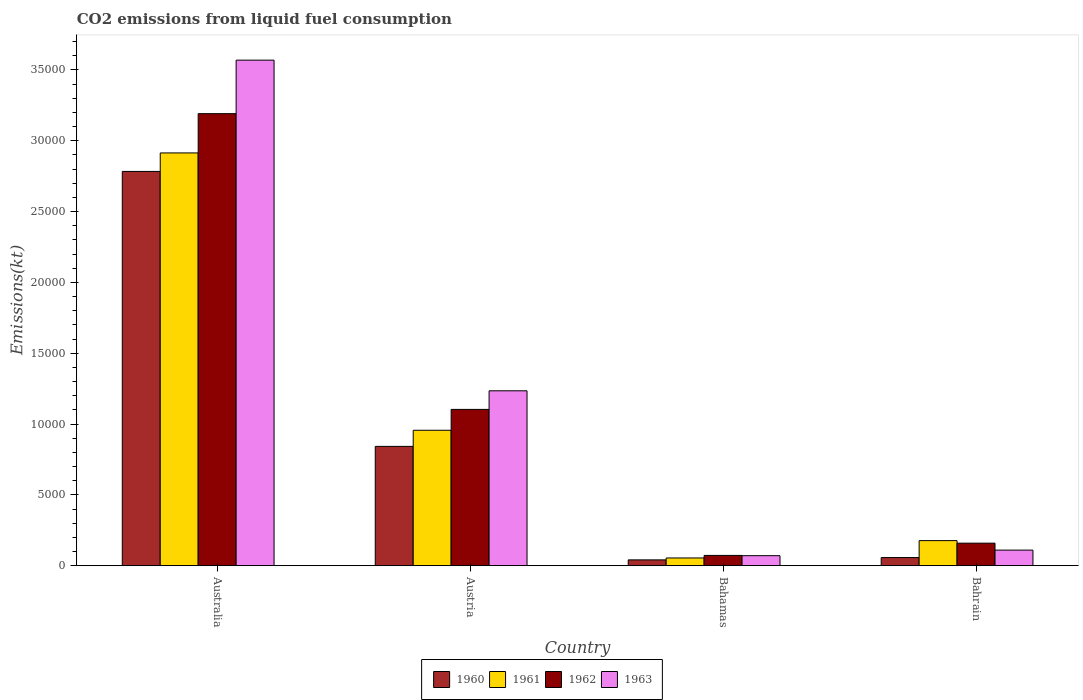How many different coloured bars are there?
Your response must be concise. 4. How many groups of bars are there?
Your response must be concise. 4. Are the number of bars on each tick of the X-axis equal?
Your response must be concise. Yes. How many bars are there on the 1st tick from the right?
Your answer should be compact. 4. What is the amount of CO2 emitted in 1961 in Austria?
Give a very brief answer. 9559.87. Across all countries, what is the maximum amount of CO2 emitted in 1963?
Your response must be concise. 3.57e+04. Across all countries, what is the minimum amount of CO2 emitted in 1960?
Offer a very short reply. 410.7. In which country was the amount of CO2 emitted in 1960 minimum?
Your answer should be very brief. Bahamas. What is the total amount of CO2 emitted in 1962 in the graph?
Keep it short and to the point. 4.53e+04. What is the difference between the amount of CO2 emitted in 1962 in Australia and that in Bahamas?
Your response must be concise. 3.12e+04. What is the difference between the amount of CO2 emitted in 1960 in Austria and the amount of CO2 emitted in 1963 in Australia?
Give a very brief answer. -2.73e+04. What is the average amount of CO2 emitted in 1960 per country?
Offer a terse response. 9310.51. What is the difference between the amount of CO2 emitted of/in 1963 and amount of CO2 emitted of/in 1961 in Austria?
Your answer should be compact. 2786.92. In how many countries, is the amount of CO2 emitted in 1963 greater than 11000 kt?
Make the answer very short. 2. What is the ratio of the amount of CO2 emitted in 1962 in Australia to that in Bahamas?
Give a very brief answer. 43.95. Is the difference between the amount of CO2 emitted in 1963 in Austria and Bahrain greater than the difference between the amount of CO2 emitted in 1961 in Austria and Bahrain?
Provide a short and direct response. Yes. What is the difference between the highest and the second highest amount of CO2 emitted in 1960?
Your response must be concise. 2.73e+04. What is the difference between the highest and the lowest amount of CO2 emitted in 1960?
Offer a terse response. 2.74e+04. In how many countries, is the amount of CO2 emitted in 1963 greater than the average amount of CO2 emitted in 1963 taken over all countries?
Your answer should be very brief. 1. What does the 3rd bar from the right in Australia represents?
Your response must be concise. 1961. Is it the case that in every country, the sum of the amount of CO2 emitted in 1961 and amount of CO2 emitted in 1963 is greater than the amount of CO2 emitted in 1962?
Your answer should be compact. Yes. How many bars are there?
Your answer should be compact. 16. Are all the bars in the graph horizontal?
Ensure brevity in your answer.  No. What is the difference between two consecutive major ticks on the Y-axis?
Offer a very short reply. 5000. Are the values on the major ticks of Y-axis written in scientific E-notation?
Make the answer very short. No. Does the graph contain any zero values?
Your response must be concise. No. Does the graph contain grids?
Keep it short and to the point. No. Where does the legend appear in the graph?
Make the answer very short. Bottom center. How many legend labels are there?
Your answer should be compact. 4. How are the legend labels stacked?
Provide a short and direct response. Horizontal. What is the title of the graph?
Offer a terse response. CO2 emissions from liquid fuel consumption. What is the label or title of the X-axis?
Your response must be concise. Country. What is the label or title of the Y-axis?
Provide a succinct answer. Emissions(kt). What is the Emissions(kt) of 1960 in Australia?
Offer a very short reply. 2.78e+04. What is the Emissions(kt) of 1961 in Australia?
Give a very brief answer. 2.91e+04. What is the Emissions(kt) of 1962 in Australia?
Your answer should be very brief. 3.19e+04. What is the Emissions(kt) in 1963 in Australia?
Keep it short and to the point. 3.57e+04. What is the Emissions(kt) of 1960 in Austria?
Offer a terse response. 8423.1. What is the Emissions(kt) of 1961 in Austria?
Ensure brevity in your answer.  9559.87. What is the Emissions(kt) of 1962 in Austria?
Ensure brevity in your answer.  1.10e+04. What is the Emissions(kt) in 1963 in Austria?
Your answer should be very brief. 1.23e+04. What is the Emissions(kt) of 1960 in Bahamas?
Keep it short and to the point. 410.7. What is the Emissions(kt) in 1961 in Bahamas?
Provide a short and direct response. 546.38. What is the Emissions(kt) in 1962 in Bahamas?
Keep it short and to the point. 726.07. What is the Emissions(kt) in 1963 in Bahamas?
Provide a short and direct response. 707.73. What is the Emissions(kt) in 1960 in Bahrain?
Your answer should be compact. 575.72. What is the Emissions(kt) in 1961 in Bahrain?
Provide a short and direct response. 1771.16. What is the Emissions(kt) of 1962 in Bahrain?
Offer a terse response. 1591.48. What is the Emissions(kt) of 1963 in Bahrain?
Offer a very short reply. 1100.1. Across all countries, what is the maximum Emissions(kt) in 1960?
Provide a succinct answer. 2.78e+04. Across all countries, what is the maximum Emissions(kt) of 1961?
Provide a short and direct response. 2.91e+04. Across all countries, what is the maximum Emissions(kt) of 1962?
Provide a succinct answer. 3.19e+04. Across all countries, what is the maximum Emissions(kt) of 1963?
Give a very brief answer. 3.57e+04. Across all countries, what is the minimum Emissions(kt) in 1960?
Provide a short and direct response. 410.7. Across all countries, what is the minimum Emissions(kt) in 1961?
Your answer should be compact. 546.38. Across all countries, what is the minimum Emissions(kt) of 1962?
Keep it short and to the point. 726.07. Across all countries, what is the minimum Emissions(kt) in 1963?
Your response must be concise. 707.73. What is the total Emissions(kt) of 1960 in the graph?
Provide a short and direct response. 3.72e+04. What is the total Emissions(kt) in 1961 in the graph?
Keep it short and to the point. 4.10e+04. What is the total Emissions(kt) in 1962 in the graph?
Your answer should be very brief. 4.53e+04. What is the total Emissions(kt) in 1963 in the graph?
Your response must be concise. 4.98e+04. What is the difference between the Emissions(kt) of 1960 in Australia and that in Austria?
Your response must be concise. 1.94e+04. What is the difference between the Emissions(kt) of 1961 in Australia and that in Austria?
Ensure brevity in your answer.  1.96e+04. What is the difference between the Emissions(kt) in 1962 in Australia and that in Austria?
Give a very brief answer. 2.09e+04. What is the difference between the Emissions(kt) of 1963 in Australia and that in Austria?
Offer a terse response. 2.33e+04. What is the difference between the Emissions(kt) of 1960 in Australia and that in Bahamas?
Offer a very short reply. 2.74e+04. What is the difference between the Emissions(kt) of 1961 in Australia and that in Bahamas?
Your response must be concise. 2.86e+04. What is the difference between the Emissions(kt) in 1962 in Australia and that in Bahamas?
Offer a very short reply. 3.12e+04. What is the difference between the Emissions(kt) of 1963 in Australia and that in Bahamas?
Keep it short and to the point. 3.50e+04. What is the difference between the Emissions(kt) of 1960 in Australia and that in Bahrain?
Your answer should be very brief. 2.73e+04. What is the difference between the Emissions(kt) in 1961 in Australia and that in Bahrain?
Offer a very short reply. 2.74e+04. What is the difference between the Emissions(kt) in 1962 in Australia and that in Bahrain?
Provide a short and direct response. 3.03e+04. What is the difference between the Emissions(kt) of 1963 in Australia and that in Bahrain?
Provide a short and direct response. 3.46e+04. What is the difference between the Emissions(kt) in 1960 in Austria and that in Bahamas?
Ensure brevity in your answer.  8012.4. What is the difference between the Emissions(kt) in 1961 in Austria and that in Bahamas?
Your answer should be very brief. 9013.49. What is the difference between the Emissions(kt) in 1962 in Austria and that in Bahamas?
Offer a very short reply. 1.03e+04. What is the difference between the Emissions(kt) in 1963 in Austria and that in Bahamas?
Make the answer very short. 1.16e+04. What is the difference between the Emissions(kt) of 1960 in Austria and that in Bahrain?
Your response must be concise. 7847.38. What is the difference between the Emissions(kt) in 1961 in Austria and that in Bahrain?
Provide a succinct answer. 7788.71. What is the difference between the Emissions(kt) of 1962 in Austria and that in Bahrain?
Give a very brief answer. 9442.52. What is the difference between the Emissions(kt) in 1963 in Austria and that in Bahrain?
Keep it short and to the point. 1.12e+04. What is the difference between the Emissions(kt) in 1960 in Bahamas and that in Bahrain?
Give a very brief answer. -165.01. What is the difference between the Emissions(kt) in 1961 in Bahamas and that in Bahrain?
Offer a terse response. -1224.78. What is the difference between the Emissions(kt) of 1962 in Bahamas and that in Bahrain?
Offer a very short reply. -865.41. What is the difference between the Emissions(kt) of 1963 in Bahamas and that in Bahrain?
Give a very brief answer. -392.37. What is the difference between the Emissions(kt) of 1960 in Australia and the Emissions(kt) of 1961 in Austria?
Your answer should be very brief. 1.83e+04. What is the difference between the Emissions(kt) in 1960 in Australia and the Emissions(kt) in 1962 in Austria?
Keep it short and to the point. 1.68e+04. What is the difference between the Emissions(kt) in 1960 in Australia and the Emissions(kt) in 1963 in Austria?
Give a very brief answer. 1.55e+04. What is the difference between the Emissions(kt) of 1961 in Australia and the Emissions(kt) of 1962 in Austria?
Give a very brief answer. 1.81e+04. What is the difference between the Emissions(kt) of 1961 in Australia and the Emissions(kt) of 1963 in Austria?
Offer a very short reply. 1.68e+04. What is the difference between the Emissions(kt) of 1962 in Australia and the Emissions(kt) of 1963 in Austria?
Your answer should be very brief. 1.96e+04. What is the difference between the Emissions(kt) in 1960 in Australia and the Emissions(kt) in 1961 in Bahamas?
Give a very brief answer. 2.73e+04. What is the difference between the Emissions(kt) in 1960 in Australia and the Emissions(kt) in 1962 in Bahamas?
Your response must be concise. 2.71e+04. What is the difference between the Emissions(kt) of 1960 in Australia and the Emissions(kt) of 1963 in Bahamas?
Ensure brevity in your answer.  2.71e+04. What is the difference between the Emissions(kt) of 1961 in Australia and the Emissions(kt) of 1962 in Bahamas?
Give a very brief answer. 2.84e+04. What is the difference between the Emissions(kt) in 1961 in Australia and the Emissions(kt) in 1963 in Bahamas?
Keep it short and to the point. 2.84e+04. What is the difference between the Emissions(kt) of 1962 in Australia and the Emissions(kt) of 1963 in Bahamas?
Offer a very short reply. 3.12e+04. What is the difference between the Emissions(kt) of 1960 in Australia and the Emissions(kt) of 1961 in Bahrain?
Make the answer very short. 2.61e+04. What is the difference between the Emissions(kt) in 1960 in Australia and the Emissions(kt) in 1962 in Bahrain?
Provide a short and direct response. 2.62e+04. What is the difference between the Emissions(kt) in 1960 in Australia and the Emissions(kt) in 1963 in Bahrain?
Keep it short and to the point. 2.67e+04. What is the difference between the Emissions(kt) in 1961 in Australia and the Emissions(kt) in 1962 in Bahrain?
Ensure brevity in your answer.  2.75e+04. What is the difference between the Emissions(kt) of 1961 in Australia and the Emissions(kt) of 1963 in Bahrain?
Provide a succinct answer. 2.80e+04. What is the difference between the Emissions(kt) of 1962 in Australia and the Emissions(kt) of 1963 in Bahrain?
Offer a very short reply. 3.08e+04. What is the difference between the Emissions(kt) in 1960 in Austria and the Emissions(kt) in 1961 in Bahamas?
Your answer should be compact. 7876.72. What is the difference between the Emissions(kt) in 1960 in Austria and the Emissions(kt) in 1962 in Bahamas?
Provide a short and direct response. 7697.03. What is the difference between the Emissions(kt) of 1960 in Austria and the Emissions(kt) of 1963 in Bahamas?
Make the answer very short. 7715.37. What is the difference between the Emissions(kt) of 1961 in Austria and the Emissions(kt) of 1962 in Bahamas?
Provide a short and direct response. 8833.8. What is the difference between the Emissions(kt) in 1961 in Austria and the Emissions(kt) in 1963 in Bahamas?
Offer a very short reply. 8852.14. What is the difference between the Emissions(kt) in 1962 in Austria and the Emissions(kt) in 1963 in Bahamas?
Keep it short and to the point. 1.03e+04. What is the difference between the Emissions(kt) in 1960 in Austria and the Emissions(kt) in 1961 in Bahrain?
Your response must be concise. 6651.94. What is the difference between the Emissions(kt) in 1960 in Austria and the Emissions(kt) in 1962 in Bahrain?
Your answer should be compact. 6831.62. What is the difference between the Emissions(kt) in 1960 in Austria and the Emissions(kt) in 1963 in Bahrain?
Your answer should be very brief. 7323. What is the difference between the Emissions(kt) of 1961 in Austria and the Emissions(kt) of 1962 in Bahrain?
Your answer should be compact. 7968.39. What is the difference between the Emissions(kt) in 1961 in Austria and the Emissions(kt) in 1963 in Bahrain?
Provide a short and direct response. 8459.77. What is the difference between the Emissions(kt) of 1962 in Austria and the Emissions(kt) of 1963 in Bahrain?
Your response must be concise. 9933.9. What is the difference between the Emissions(kt) of 1960 in Bahamas and the Emissions(kt) of 1961 in Bahrain?
Give a very brief answer. -1360.46. What is the difference between the Emissions(kt) of 1960 in Bahamas and the Emissions(kt) of 1962 in Bahrain?
Your answer should be compact. -1180.77. What is the difference between the Emissions(kt) in 1960 in Bahamas and the Emissions(kt) in 1963 in Bahrain?
Give a very brief answer. -689.4. What is the difference between the Emissions(kt) of 1961 in Bahamas and the Emissions(kt) of 1962 in Bahrain?
Provide a succinct answer. -1045.1. What is the difference between the Emissions(kt) in 1961 in Bahamas and the Emissions(kt) in 1963 in Bahrain?
Provide a short and direct response. -553.72. What is the difference between the Emissions(kt) of 1962 in Bahamas and the Emissions(kt) of 1963 in Bahrain?
Ensure brevity in your answer.  -374.03. What is the average Emissions(kt) in 1960 per country?
Make the answer very short. 9310.51. What is the average Emissions(kt) of 1961 per country?
Make the answer very short. 1.03e+04. What is the average Emissions(kt) of 1962 per country?
Give a very brief answer. 1.13e+04. What is the average Emissions(kt) in 1963 per country?
Your response must be concise. 1.25e+04. What is the difference between the Emissions(kt) in 1960 and Emissions(kt) in 1961 in Australia?
Ensure brevity in your answer.  -1305.45. What is the difference between the Emissions(kt) in 1960 and Emissions(kt) in 1962 in Australia?
Offer a terse response. -4077.7. What is the difference between the Emissions(kt) of 1960 and Emissions(kt) of 1963 in Australia?
Give a very brief answer. -7854.71. What is the difference between the Emissions(kt) in 1961 and Emissions(kt) in 1962 in Australia?
Your answer should be very brief. -2772.25. What is the difference between the Emissions(kt) in 1961 and Emissions(kt) in 1963 in Australia?
Provide a short and direct response. -6549.26. What is the difference between the Emissions(kt) of 1962 and Emissions(kt) of 1963 in Australia?
Provide a short and direct response. -3777.01. What is the difference between the Emissions(kt) in 1960 and Emissions(kt) in 1961 in Austria?
Offer a very short reply. -1136.77. What is the difference between the Emissions(kt) in 1960 and Emissions(kt) in 1962 in Austria?
Offer a very short reply. -2610.9. What is the difference between the Emissions(kt) of 1960 and Emissions(kt) of 1963 in Austria?
Keep it short and to the point. -3923.69. What is the difference between the Emissions(kt) of 1961 and Emissions(kt) of 1962 in Austria?
Make the answer very short. -1474.13. What is the difference between the Emissions(kt) in 1961 and Emissions(kt) in 1963 in Austria?
Your response must be concise. -2786.92. What is the difference between the Emissions(kt) in 1962 and Emissions(kt) in 1963 in Austria?
Provide a succinct answer. -1312.79. What is the difference between the Emissions(kt) in 1960 and Emissions(kt) in 1961 in Bahamas?
Keep it short and to the point. -135.68. What is the difference between the Emissions(kt) in 1960 and Emissions(kt) in 1962 in Bahamas?
Make the answer very short. -315.36. What is the difference between the Emissions(kt) in 1960 and Emissions(kt) in 1963 in Bahamas?
Make the answer very short. -297.03. What is the difference between the Emissions(kt) in 1961 and Emissions(kt) in 1962 in Bahamas?
Your answer should be very brief. -179.68. What is the difference between the Emissions(kt) of 1961 and Emissions(kt) of 1963 in Bahamas?
Offer a terse response. -161.35. What is the difference between the Emissions(kt) of 1962 and Emissions(kt) of 1963 in Bahamas?
Offer a very short reply. 18.34. What is the difference between the Emissions(kt) in 1960 and Emissions(kt) in 1961 in Bahrain?
Provide a short and direct response. -1195.44. What is the difference between the Emissions(kt) of 1960 and Emissions(kt) of 1962 in Bahrain?
Offer a terse response. -1015.76. What is the difference between the Emissions(kt) of 1960 and Emissions(kt) of 1963 in Bahrain?
Offer a terse response. -524.38. What is the difference between the Emissions(kt) of 1961 and Emissions(kt) of 1962 in Bahrain?
Your response must be concise. 179.68. What is the difference between the Emissions(kt) of 1961 and Emissions(kt) of 1963 in Bahrain?
Ensure brevity in your answer.  671.06. What is the difference between the Emissions(kt) in 1962 and Emissions(kt) in 1963 in Bahrain?
Offer a terse response. 491.38. What is the ratio of the Emissions(kt) in 1960 in Australia to that in Austria?
Provide a short and direct response. 3.3. What is the ratio of the Emissions(kt) of 1961 in Australia to that in Austria?
Provide a short and direct response. 3.05. What is the ratio of the Emissions(kt) in 1962 in Australia to that in Austria?
Ensure brevity in your answer.  2.89. What is the ratio of the Emissions(kt) in 1963 in Australia to that in Austria?
Keep it short and to the point. 2.89. What is the ratio of the Emissions(kt) of 1960 in Australia to that in Bahamas?
Your answer should be compact. 67.77. What is the ratio of the Emissions(kt) in 1961 in Australia to that in Bahamas?
Keep it short and to the point. 53.33. What is the ratio of the Emissions(kt) in 1962 in Australia to that in Bahamas?
Keep it short and to the point. 43.95. What is the ratio of the Emissions(kt) in 1963 in Australia to that in Bahamas?
Provide a succinct answer. 50.42. What is the ratio of the Emissions(kt) of 1960 in Australia to that in Bahrain?
Make the answer very short. 48.34. What is the ratio of the Emissions(kt) of 1961 in Australia to that in Bahrain?
Your answer should be very brief. 16.45. What is the ratio of the Emissions(kt) of 1962 in Australia to that in Bahrain?
Make the answer very short. 20.05. What is the ratio of the Emissions(kt) in 1963 in Australia to that in Bahrain?
Offer a terse response. 32.44. What is the ratio of the Emissions(kt) in 1960 in Austria to that in Bahamas?
Offer a very short reply. 20.51. What is the ratio of the Emissions(kt) in 1961 in Austria to that in Bahamas?
Your answer should be compact. 17.5. What is the ratio of the Emissions(kt) in 1962 in Austria to that in Bahamas?
Offer a terse response. 15.2. What is the ratio of the Emissions(kt) in 1963 in Austria to that in Bahamas?
Your answer should be compact. 17.45. What is the ratio of the Emissions(kt) in 1960 in Austria to that in Bahrain?
Ensure brevity in your answer.  14.63. What is the ratio of the Emissions(kt) of 1961 in Austria to that in Bahrain?
Provide a succinct answer. 5.4. What is the ratio of the Emissions(kt) of 1962 in Austria to that in Bahrain?
Provide a short and direct response. 6.93. What is the ratio of the Emissions(kt) of 1963 in Austria to that in Bahrain?
Your response must be concise. 11.22. What is the ratio of the Emissions(kt) of 1960 in Bahamas to that in Bahrain?
Offer a very short reply. 0.71. What is the ratio of the Emissions(kt) of 1961 in Bahamas to that in Bahrain?
Make the answer very short. 0.31. What is the ratio of the Emissions(kt) in 1962 in Bahamas to that in Bahrain?
Ensure brevity in your answer.  0.46. What is the ratio of the Emissions(kt) of 1963 in Bahamas to that in Bahrain?
Offer a very short reply. 0.64. What is the difference between the highest and the second highest Emissions(kt) in 1960?
Provide a short and direct response. 1.94e+04. What is the difference between the highest and the second highest Emissions(kt) of 1961?
Provide a succinct answer. 1.96e+04. What is the difference between the highest and the second highest Emissions(kt) of 1962?
Your answer should be very brief. 2.09e+04. What is the difference between the highest and the second highest Emissions(kt) of 1963?
Your response must be concise. 2.33e+04. What is the difference between the highest and the lowest Emissions(kt) of 1960?
Your answer should be compact. 2.74e+04. What is the difference between the highest and the lowest Emissions(kt) of 1961?
Keep it short and to the point. 2.86e+04. What is the difference between the highest and the lowest Emissions(kt) in 1962?
Provide a succinct answer. 3.12e+04. What is the difference between the highest and the lowest Emissions(kt) of 1963?
Keep it short and to the point. 3.50e+04. 